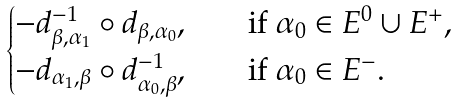<formula> <loc_0><loc_0><loc_500><loc_500>\begin{cases} - d ^ { - 1 } _ { \beta , \alpha _ { 1 } } \circ d _ { \beta , \alpha _ { 0 } } , & \quad \text {if } \alpha _ { 0 } \in E ^ { 0 } \cup E ^ { + } , \\ - d _ { \alpha _ { 1 } , \beta } \circ d ^ { - 1 } _ { \alpha _ { 0 } , \beta } , & \quad \text {if } \alpha _ { 0 } \in E ^ { - } . \end{cases}</formula> 